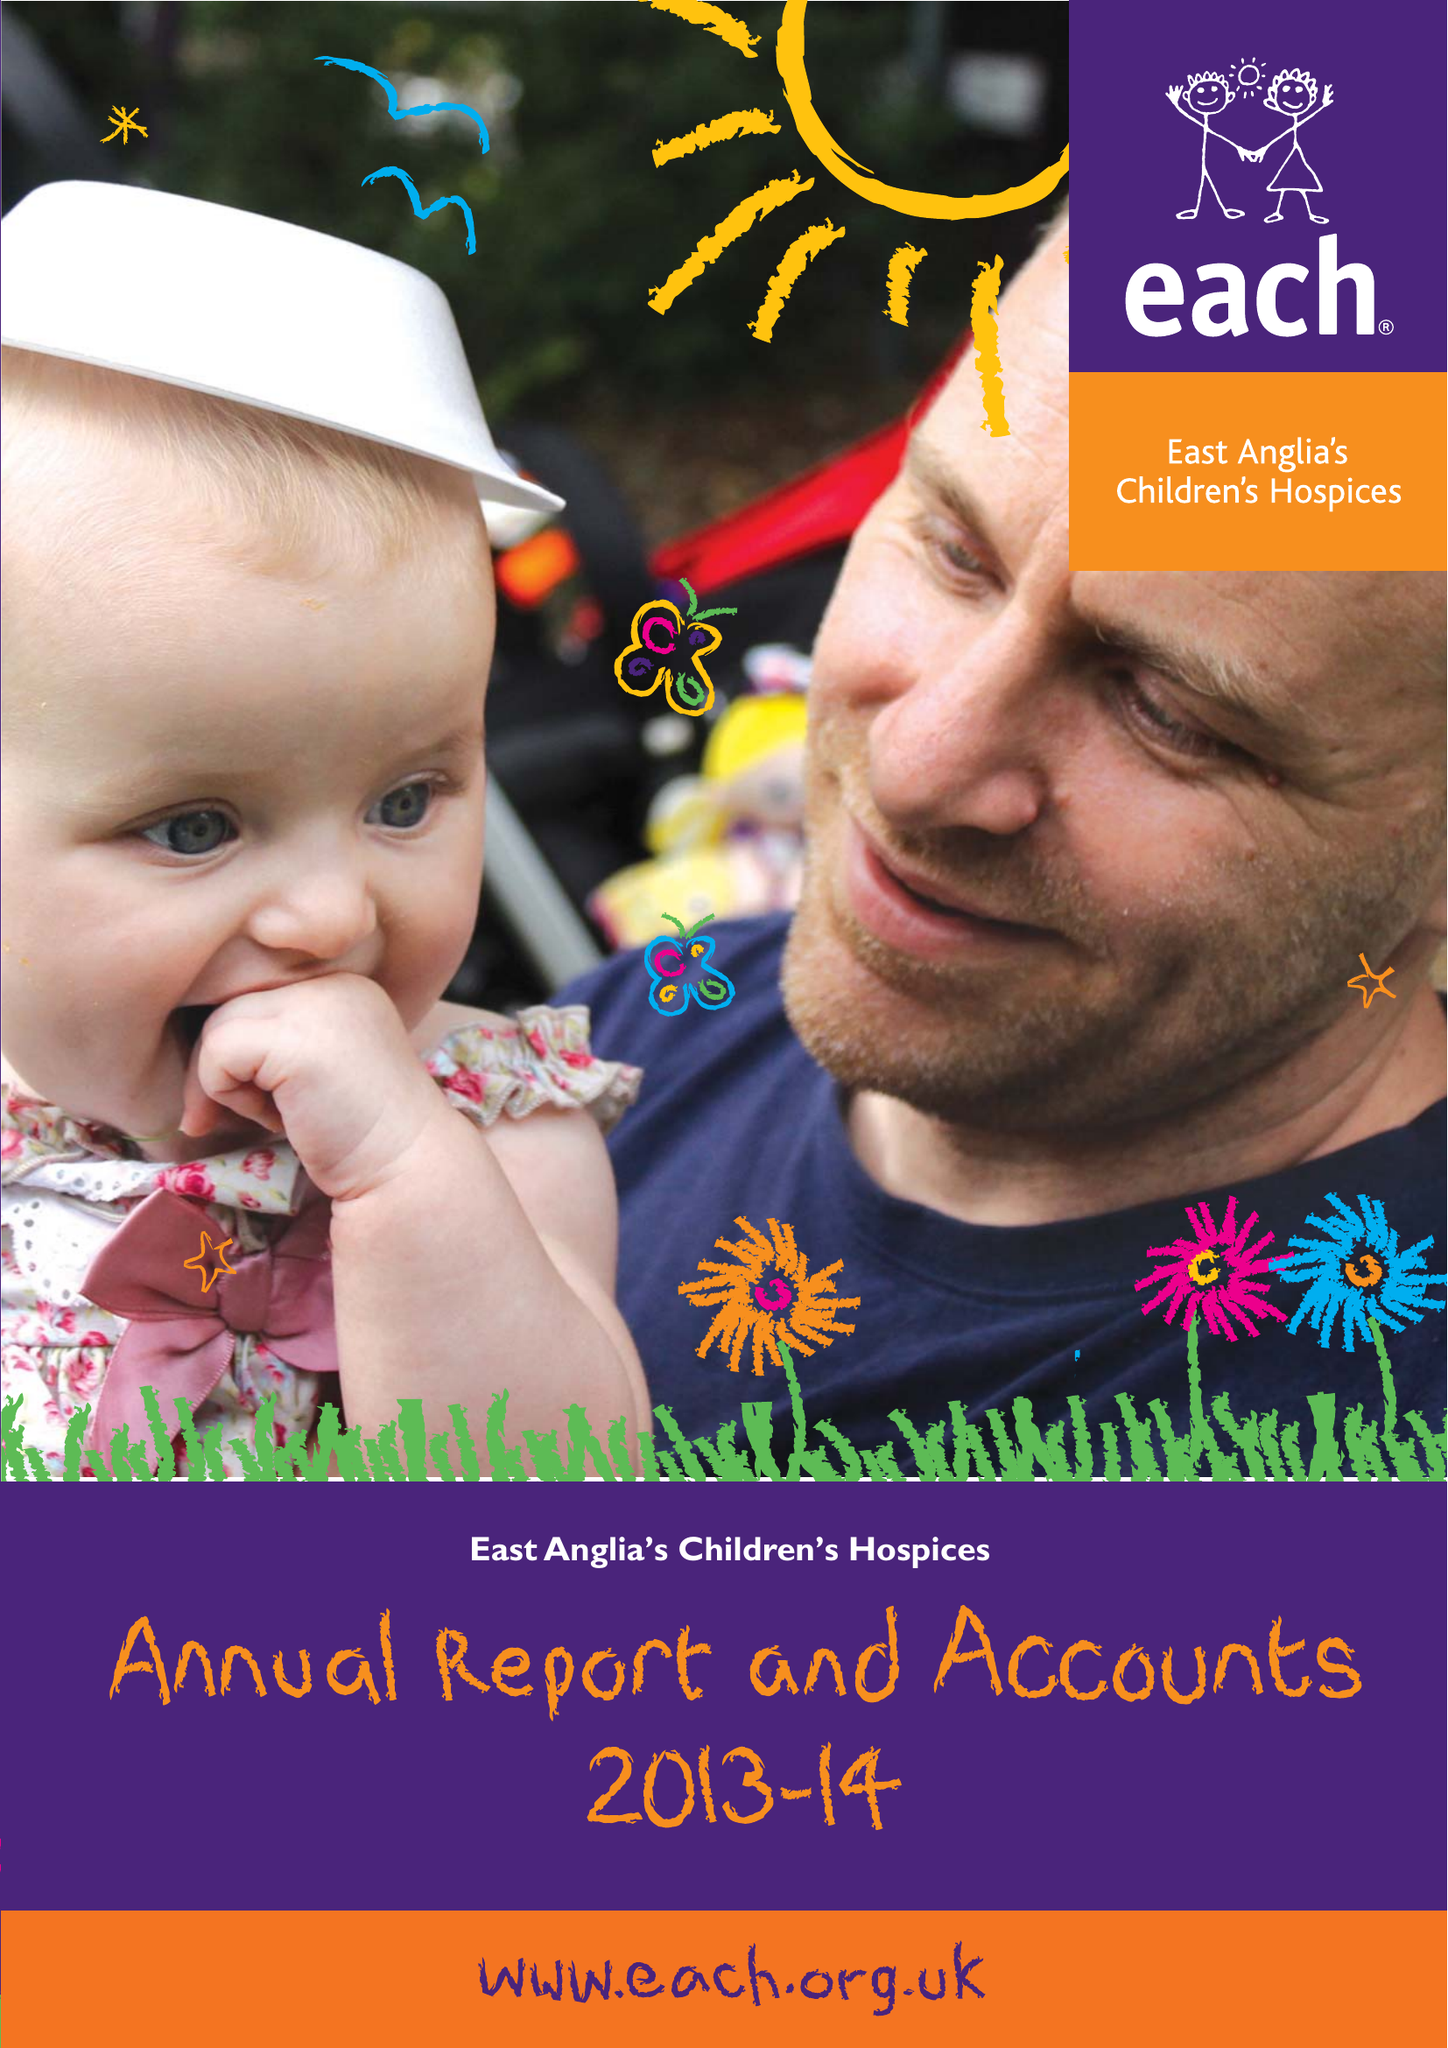What is the value for the income_annually_in_british_pounds?
Answer the question using a single word or phrase. 9973677.00 